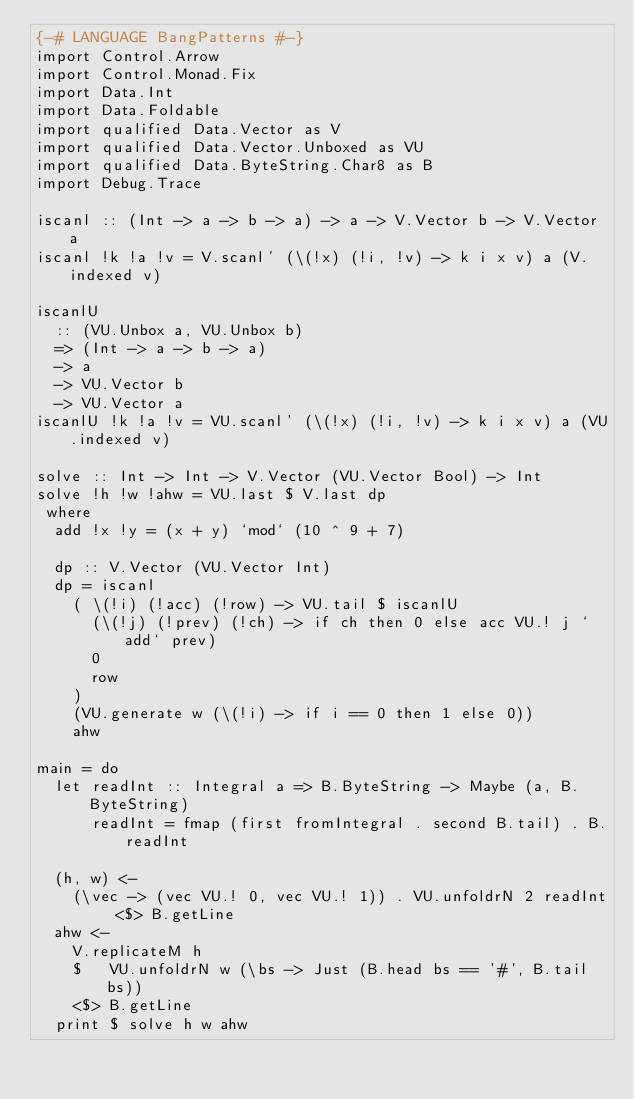<code> <loc_0><loc_0><loc_500><loc_500><_Haskell_>{-# LANGUAGE BangPatterns #-}
import Control.Arrow
import Control.Monad.Fix
import Data.Int
import Data.Foldable
import qualified Data.Vector as V
import qualified Data.Vector.Unboxed as VU
import qualified Data.ByteString.Char8 as B
import Debug.Trace

iscanl :: (Int -> a -> b -> a) -> a -> V.Vector b -> V.Vector a
iscanl !k !a !v = V.scanl' (\(!x) (!i, !v) -> k i x v) a (V.indexed v)

iscanlU
  :: (VU.Unbox a, VU.Unbox b)
  => (Int -> a -> b -> a)
  -> a
  -> VU.Vector b
  -> VU.Vector a
iscanlU !k !a !v = VU.scanl' (\(!x) (!i, !v) -> k i x v) a (VU.indexed v)

solve :: Int -> Int -> V.Vector (VU.Vector Bool) -> Int
solve !h !w !ahw = VU.last $ V.last dp
 where
  add !x !y = (x + y) `mod` (10 ^ 9 + 7)

  dp :: V.Vector (VU.Vector Int)
  dp = iscanl
    ( \(!i) (!acc) (!row) -> VU.tail $ iscanlU
      (\(!j) (!prev) (!ch) -> if ch then 0 else acc VU.! j `add` prev)
      0
      row
    )
    (VU.generate w (\(!i) -> if i == 0 then 1 else 0))
    ahw

main = do
  let readInt :: Integral a => B.ByteString -> Maybe (a, B.ByteString)
      readInt = fmap (first fromIntegral . second B.tail) . B.readInt

  (h, w) <-
    (\vec -> (vec VU.! 0, vec VU.! 1)) . VU.unfoldrN 2 readInt <$> B.getLine
  ahw <-
    V.replicateM h
    $   VU.unfoldrN w (\bs -> Just (B.head bs == '#', B.tail bs))
    <$> B.getLine
  print $ solve h w ahw
</code> 